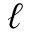Convert formula to latex. <formula><loc_0><loc_0><loc_500><loc_500>\ell</formula> 